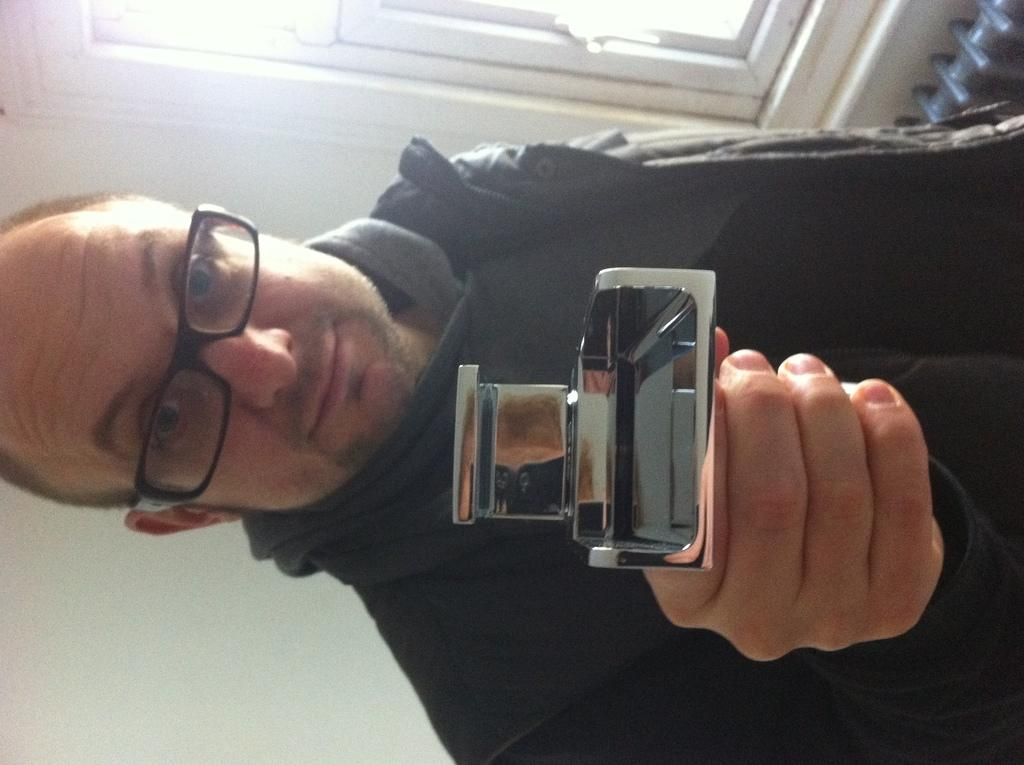What is present in the image? There is a person in the image. What is the person doing in the image? The person is holding an object. What can be seen in the background of the image? There is a window in the background of the image, and the wall is white. Is the person celebrating a holiday in the image? There is no indication of a holiday in the image. What type of umbrella is the person holding in the image? There is no umbrella present in the image. 